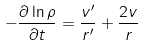<formula> <loc_0><loc_0><loc_500><loc_500>- \frac { \partial \ln \rho } { \partial t } = \frac { v ^ { \prime } } { r ^ { \prime } } + \frac { 2 v } { r }</formula> 